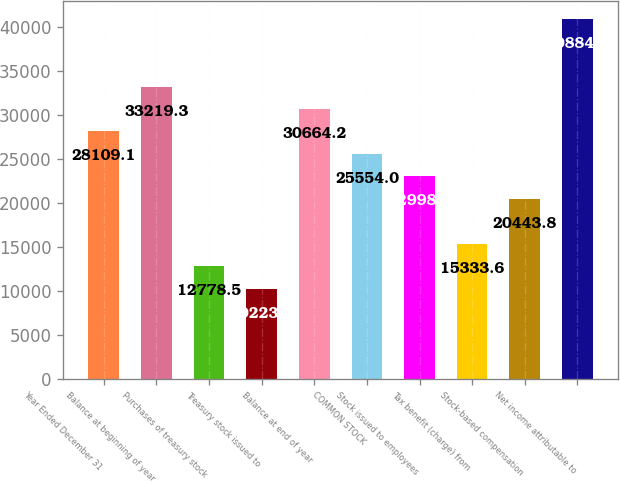Convert chart to OTSL. <chart><loc_0><loc_0><loc_500><loc_500><bar_chart><fcel>Year Ended December 31<fcel>Balance at beginning of year<fcel>Purchases of treasury stock<fcel>Treasury stock issued to<fcel>Balance at end of year<fcel>COMMON STOCK<fcel>Stock issued to employees<fcel>Tax benefit (charge) from<fcel>Stock-based compensation<fcel>Net income attributable to<nl><fcel>28109.1<fcel>33219.3<fcel>12778.5<fcel>10223.4<fcel>30664.2<fcel>25554<fcel>22998.9<fcel>15333.6<fcel>20443.8<fcel>40884.6<nl></chart> 